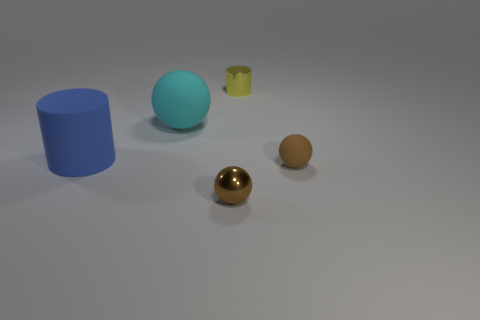Does the tiny rubber ball have the same color as the small shiny ball?
Give a very brief answer. Yes. There is a yellow cylinder; is it the same size as the metallic thing in front of the tiny yellow cylinder?
Your answer should be compact. Yes. Are any gray metallic cubes visible?
Provide a succinct answer. No. There is a big thing that is the same shape as the small yellow metallic object; what material is it?
Offer a terse response. Rubber. There is a matte ball that is to the left of the tiny thing behind the matte object to the left of the big ball; what size is it?
Ensure brevity in your answer.  Large. Are there any brown metallic things behind the small brown metallic ball?
Your answer should be very brief. No. There is a blue object that is the same material as the cyan thing; what is its size?
Your answer should be very brief. Large. How many other blue objects have the same shape as the blue object?
Offer a terse response. 0. Do the cyan ball and the cylinder in front of the cyan object have the same material?
Provide a succinct answer. Yes. Is the number of brown objects in front of the large cyan sphere greater than the number of small metal spheres?
Give a very brief answer. Yes. 